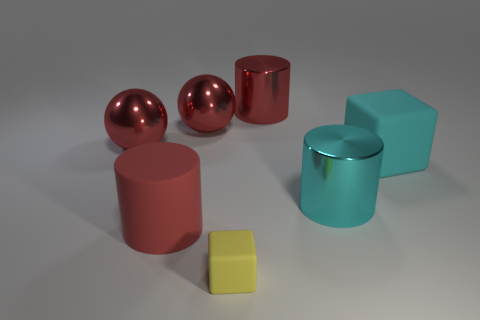Are the block right of the tiny cube and the cyan cylinder on the left side of the large cyan matte thing made of the same material?
Give a very brief answer. No. There is a big rubber block that is right of the large red object that is in front of the cube behind the large red rubber cylinder; what color is it?
Keep it short and to the point. Cyan. How many other things are there of the same shape as the tiny matte thing?
Your answer should be very brief. 1. Do the small matte cube and the big matte cylinder have the same color?
Offer a very short reply. No. What number of objects are either large shiny cylinders or large red spheres on the left side of the tiny matte cube?
Keep it short and to the point. 4. Is there a cube that has the same size as the red shiny cylinder?
Make the answer very short. Yes. Do the small block and the large cyan cylinder have the same material?
Your answer should be very brief. No. How many things are red things or tiny yellow rubber objects?
Your answer should be compact. 5. What is the size of the cyan rubber block?
Ensure brevity in your answer.  Large. Are there fewer red balls than tiny cyan blocks?
Offer a terse response. No. 